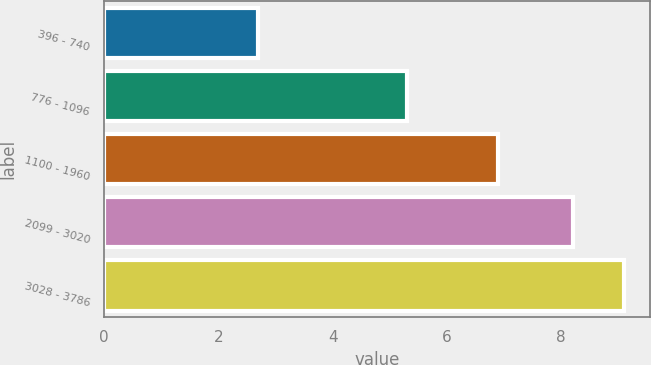Convert chart to OTSL. <chart><loc_0><loc_0><loc_500><loc_500><bar_chart><fcel>396 - 740<fcel>776 - 1096<fcel>1100 - 1960<fcel>2099 - 3020<fcel>3028 - 3786<nl><fcel>2.7<fcel>5.3<fcel>6.9<fcel>8.2<fcel>9.1<nl></chart> 